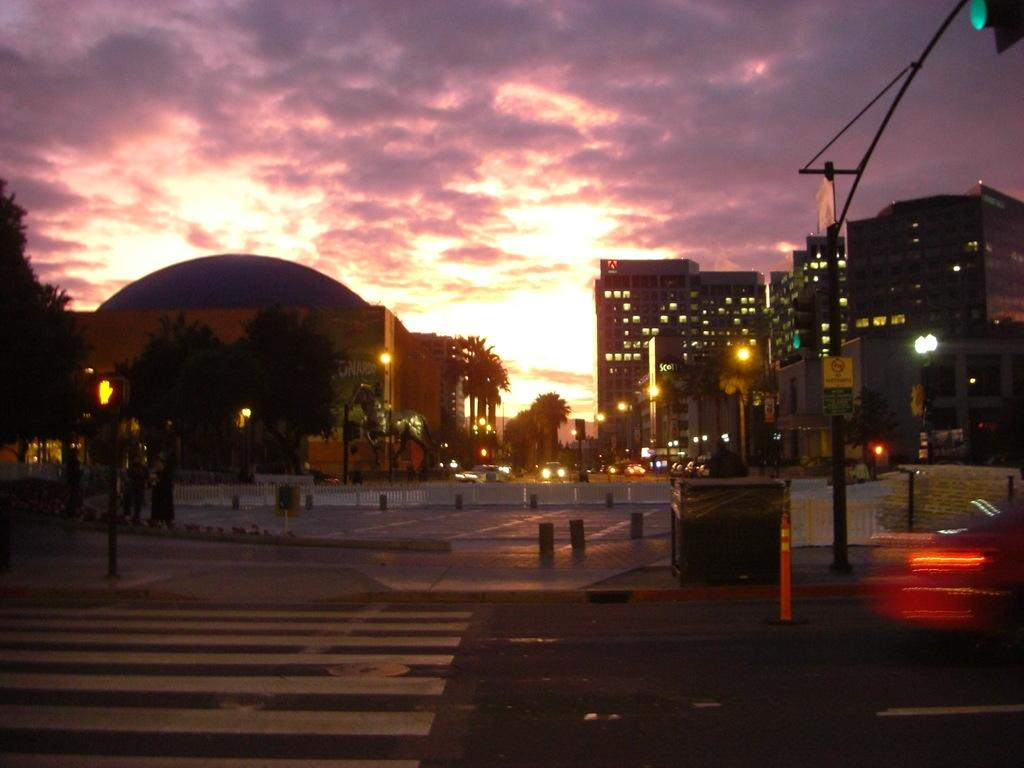What type of infrastructure is visible in the image? There is a road in the image. What else can be seen in the image besides the road? There are buildings, poles, cars, and trees on the left side of the image. What is the condition of the sky in the image? The sky is full of clouds. What is the value of the fight between the two cars in the image? There is no fight between cars in the image; it is a regular scene with cars on the road. What type of system is responsible for the organization of the poles in the image? There is no specific system mentioned or implied in the image; the poles are simply present. 